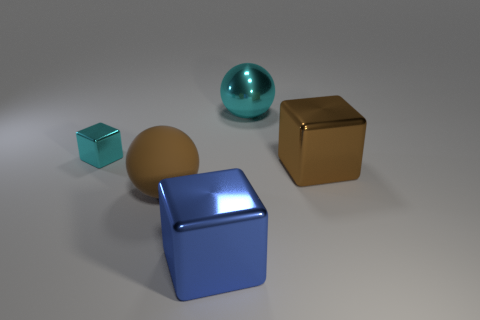How many small objects are cubes or cyan balls?
Offer a very short reply. 1. Are there an equal number of large things on the left side of the blue metal cube and big cyan metallic spheres?
Make the answer very short. Yes. Are there any small cyan shiny things behind the block that is to the left of the big brown ball?
Give a very brief answer. No. What number of other objects are there of the same color as the small shiny thing?
Your answer should be very brief. 1. What color is the matte ball?
Offer a terse response. Brown. How big is the shiny cube that is to the right of the brown sphere and on the left side of the brown block?
Make the answer very short. Large. How many objects are either large metallic cubes on the right side of the big blue thing or big red metal blocks?
Ensure brevity in your answer.  1. The big blue thing that is made of the same material as the small cube is what shape?
Your response must be concise. Cube. The small cyan shiny thing is what shape?
Provide a succinct answer. Cube. There is a thing that is to the left of the blue metal object and in front of the large brown metallic object; what is its color?
Your answer should be very brief. Brown. 